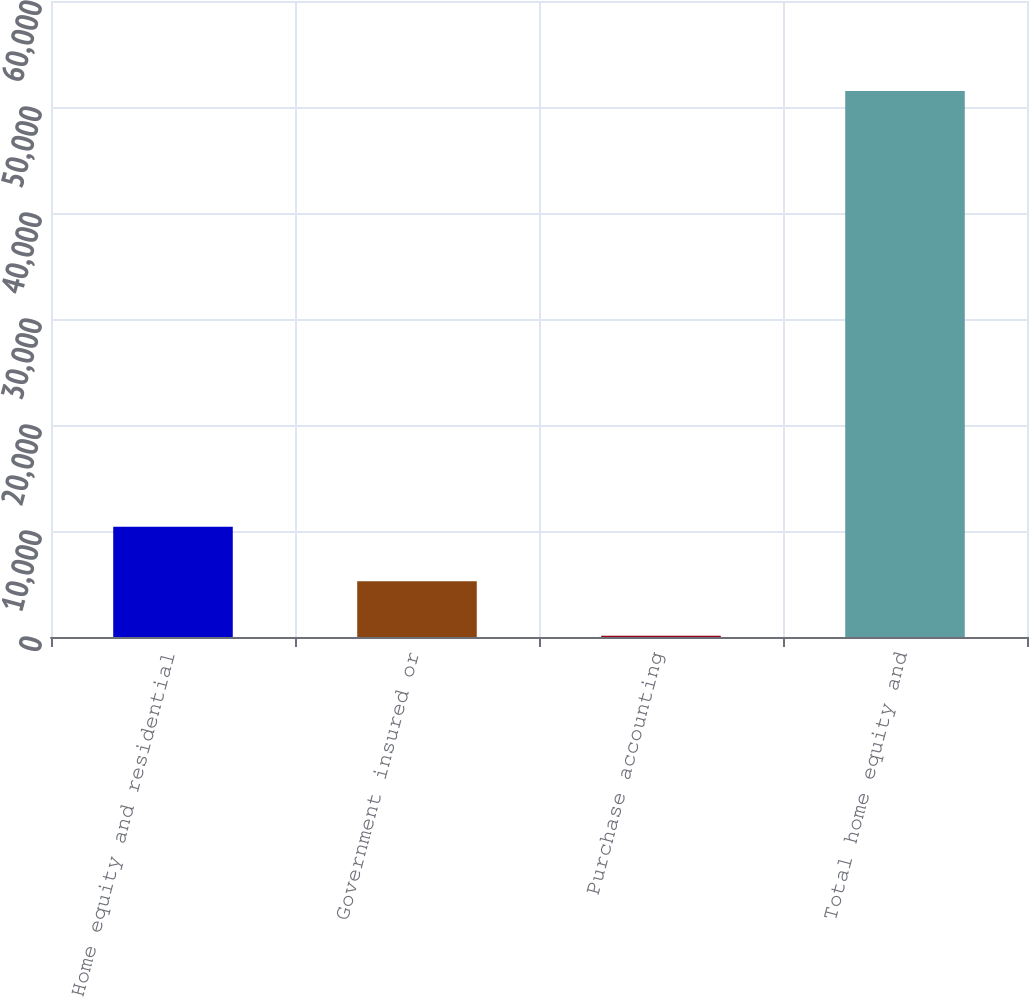Convert chart to OTSL. <chart><loc_0><loc_0><loc_500><loc_500><bar_chart><fcel>Home equity and residential<fcel>Government insured or<fcel>Purchase accounting<fcel>Total home equity and<nl><fcel>10395.2<fcel>5255.6<fcel>116<fcel>51512<nl></chart> 